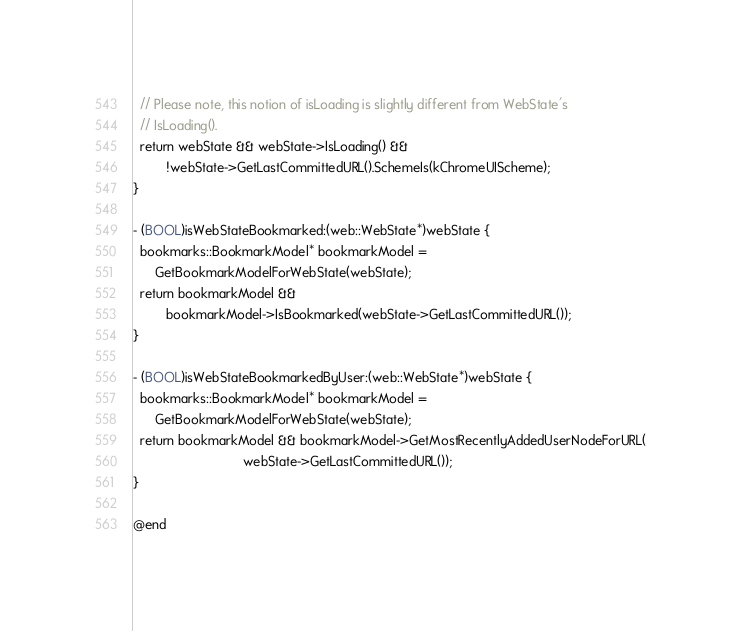Convert code to text. <code><loc_0><loc_0><loc_500><loc_500><_ObjectiveC_>  // Please note, this notion of isLoading is slightly different from WebState's
  // IsLoading().
  return webState && webState->IsLoading() &&
         !webState->GetLastCommittedURL().SchemeIs(kChromeUIScheme);
}

- (BOOL)isWebStateBookmarked:(web::WebState*)webState {
  bookmarks::BookmarkModel* bookmarkModel =
      GetBookmarkModelForWebState(webState);
  return bookmarkModel &&
         bookmarkModel->IsBookmarked(webState->GetLastCommittedURL());
}

- (BOOL)isWebStateBookmarkedByUser:(web::WebState*)webState {
  bookmarks::BookmarkModel* bookmarkModel =
      GetBookmarkModelForWebState(webState);
  return bookmarkModel && bookmarkModel->GetMostRecentlyAddedUserNodeForURL(
                              webState->GetLastCommittedURL());
}

@end
</code> 